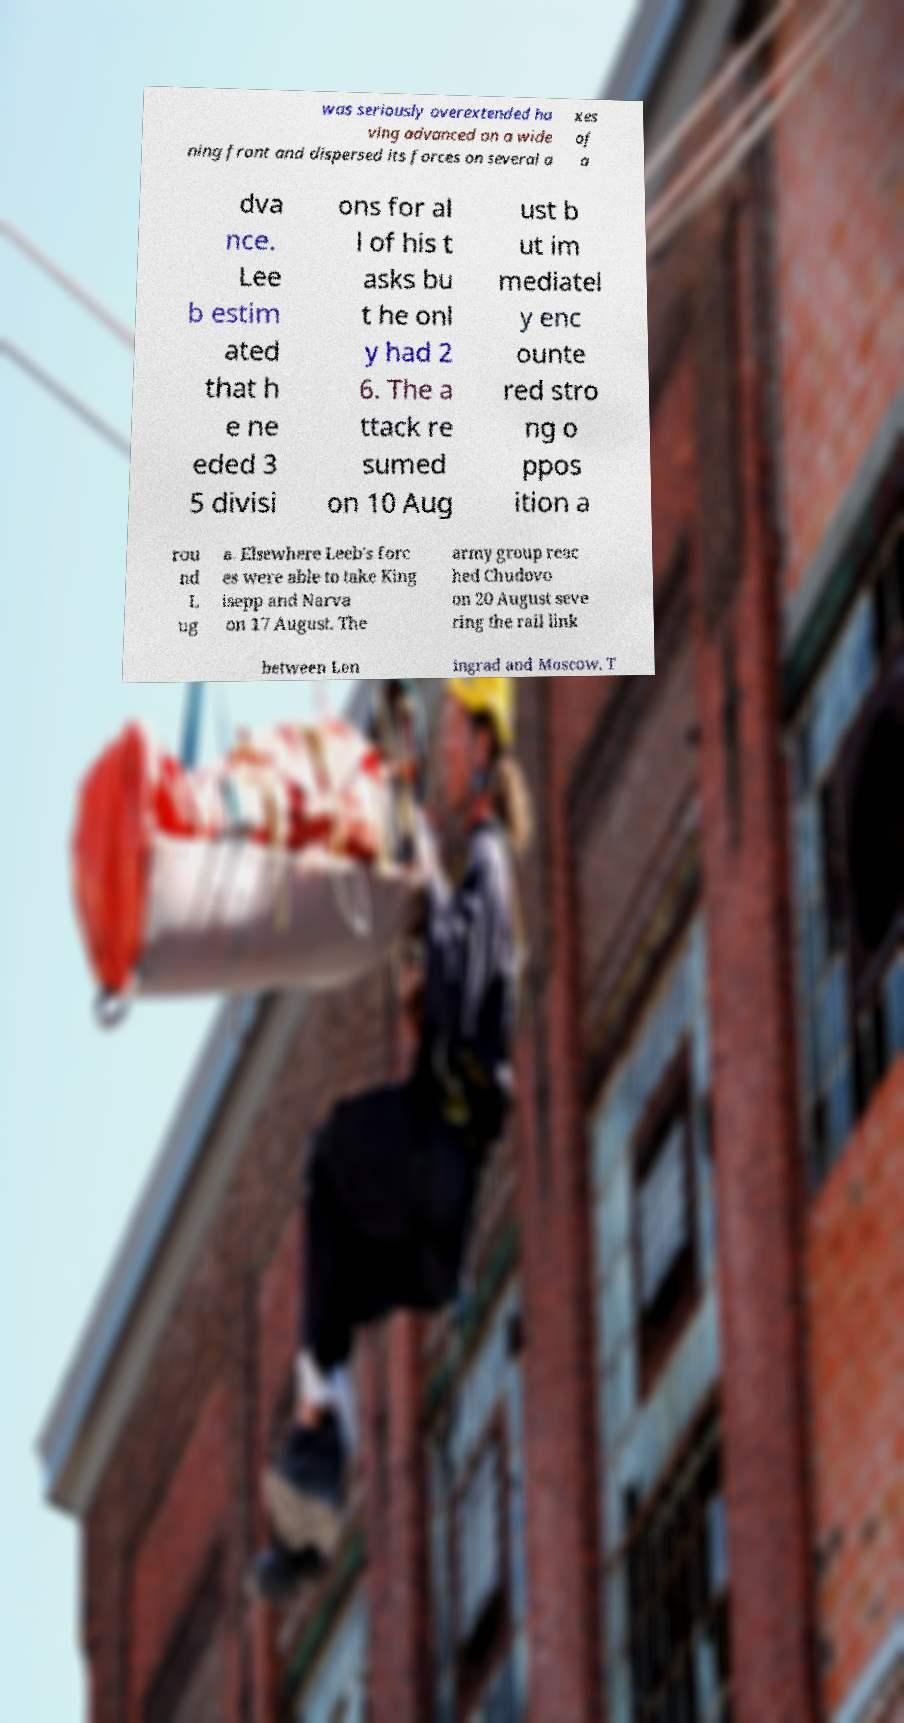For documentation purposes, I need the text within this image transcribed. Could you provide that? was seriously overextended ha ving advanced on a wide ning front and dispersed its forces on several a xes of a dva nce. Lee b estim ated that h e ne eded 3 5 divisi ons for al l of his t asks bu t he onl y had 2 6. The a ttack re sumed on 10 Aug ust b ut im mediatel y enc ounte red stro ng o ppos ition a rou nd L ug a. Elsewhere Leeb's forc es were able to take King isepp and Narva on 17 August. The army group reac hed Chudovo on 20 August seve ring the rail link between Len ingrad and Moscow. T 